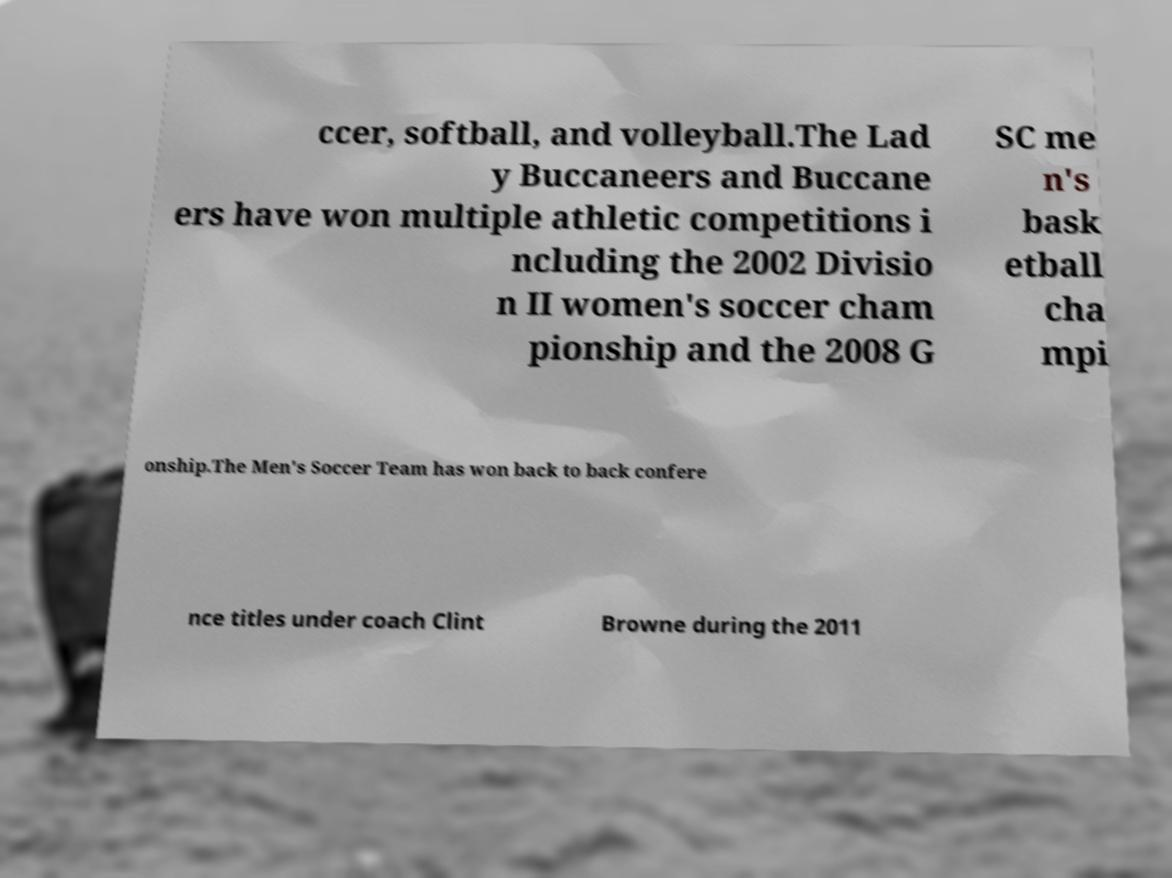For documentation purposes, I need the text within this image transcribed. Could you provide that? ccer, softball, and volleyball.The Lad y Buccaneers and Buccane ers have won multiple athletic competitions i ncluding the 2002 Divisio n II women's soccer cham pionship and the 2008 G SC me n's bask etball cha mpi onship.The Men's Soccer Team has won back to back confere nce titles under coach Clint Browne during the 2011 